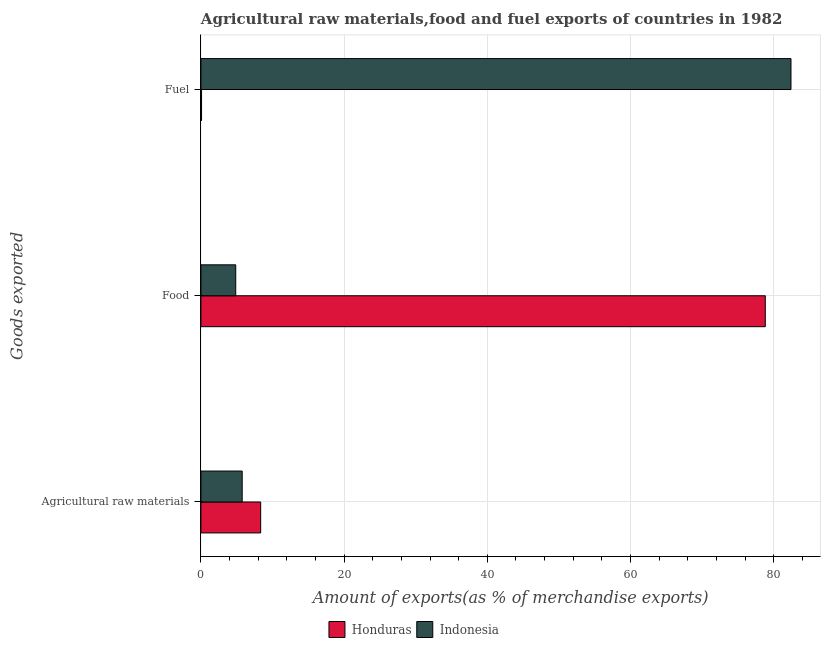How many groups of bars are there?
Your answer should be very brief. 3. Are the number of bars per tick equal to the number of legend labels?
Your answer should be very brief. Yes. What is the label of the 3rd group of bars from the top?
Your response must be concise. Agricultural raw materials. What is the percentage of food exports in Honduras?
Provide a short and direct response. 78.83. Across all countries, what is the maximum percentage of raw materials exports?
Provide a short and direct response. 8.35. Across all countries, what is the minimum percentage of food exports?
Ensure brevity in your answer.  4.86. In which country was the percentage of fuel exports maximum?
Your answer should be compact. Indonesia. What is the total percentage of fuel exports in the graph?
Your response must be concise. 82.5. What is the difference between the percentage of fuel exports in Honduras and that in Indonesia?
Your answer should be very brief. -82.33. What is the difference between the percentage of fuel exports in Indonesia and the percentage of food exports in Honduras?
Offer a terse response. 3.59. What is the average percentage of raw materials exports per country?
Provide a succinct answer. 7.05. What is the difference between the percentage of raw materials exports and percentage of fuel exports in Honduras?
Provide a succinct answer. 8.26. What is the ratio of the percentage of fuel exports in Honduras to that in Indonesia?
Your answer should be very brief. 0. Is the percentage of fuel exports in Indonesia less than that in Honduras?
Your response must be concise. No. What is the difference between the highest and the second highest percentage of food exports?
Your answer should be compact. 73.96. What is the difference between the highest and the lowest percentage of food exports?
Provide a succinct answer. 73.96. Is the sum of the percentage of fuel exports in Indonesia and Honduras greater than the maximum percentage of food exports across all countries?
Your answer should be compact. Yes. What does the 2nd bar from the top in Agricultural raw materials represents?
Offer a very short reply. Honduras. What does the 1st bar from the bottom in Agricultural raw materials represents?
Offer a terse response. Honduras. Are all the bars in the graph horizontal?
Your answer should be compact. Yes. How many countries are there in the graph?
Ensure brevity in your answer.  2. Does the graph contain any zero values?
Offer a terse response. No. Does the graph contain grids?
Your answer should be compact. Yes. Where does the legend appear in the graph?
Your response must be concise. Bottom center. How many legend labels are there?
Provide a short and direct response. 2. How are the legend labels stacked?
Your answer should be very brief. Horizontal. What is the title of the graph?
Offer a very short reply. Agricultural raw materials,food and fuel exports of countries in 1982. What is the label or title of the X-axis?
Give a very brief answer. Amount of exports(as % of merchandise exports). What is the label or title of the Y-axis?
Offer a terse response. Goods exported. What is the Amount of exports(as % of merchandise exports) of Honduras in Agricultural raw materials?
Offer a very short reply. 8.35. What is the Amount of exports(as % of merchandise exports) in Indonesia in Agricultural raw materials?
Offer a terse response. 5.76. What is the Amount of exports(as % of merchandise exports) in Honduras in Food?
Ensure brevity in your answer.  78.83. What is the Amount of exports(as % of merchandise exports) in Indonesia in Food?
Your answer should be compact. 4.86. What is the Amount of exports(as % of merchandise exports) of Honduras in Fuel?
Offer a very short reply. 0.09. What is the Amount of exports(as % of merchandise exports) in Indonesia in Fuel?
Offer a terse response. 82.41. Across all Goods exported, what is the maximum Amount of exports(as % of merchandise exports) in Honduras?
Offer a very short reply. 78.83. Across all Goods exported, what is the maximum Amount of exports(as % of merchandise exports) of Indonesia?
Offer a very short reply. 82.41. Across all Goods exported, what is the minimum Amount of exports(as % of merchandise exports) of Honduras?
Provide a short and direct response. 0.09. Across all Goods exported, what is the minimum Amount of exports(as % of merchandise exports) in Indonesia?
Your response must be concise. 4.86. What is the total Amount of exports(as % of merchandise exports) of Honduras in the graph?
Offer a terse response. 87.26. What is the total Amount of exports(as % of merchandise exports) in Indonesia in the graph?
Offer a terse response. 93.04. What is the difference between the Amount of exports(as % of merchandise exports) in Honduras in Agricultural raw materials and that in Food?
Provide a succinct answer. -70.48. What is the difference between the Amount of exports(as % of merchandise exports) in Indonesia in Agricultural raw materials and that in Food?
Make the answer very short. 0.9. What is the difference between the Amount of exports(as % of merchandise exports) in Honduras in Agricultural raw materials and that in Fuel?
Make the answer very short. 8.26. What is the difference between the Amount of exports(as % of merchandise exports) in Indonesia in Agricultural raw materials and that in Fuel?
Make the answer very short. -76.65. What is the difference between the Amount of exports(as % of merchandise exports) in Honduras in Food and that in Fuel?
Your answer should be very brief. 78.74. What is the difference between the Amount of exports(as % of merchandise exports) of Indonesia in Food and that in Fuel?
Provide a succinct answer. -77.55. What is the difference between the Amount of exports(as % of merchandise exports) of Honduras in Agricultural raw materials and the Amount of exports(as % of merchandise exports) of Indonesia in Food?
Your response must be concise. 3.48. What is the difference between the Amount of exports(as % of merchandise exports) in Honduras in Agricultural raw materials and the Amount of exports(as % of merchandise exports) in Indonesia in Fuel?
Your response must be concise. -74.07. What is the difference between the Amount of exports(as % of merchandise exports) of Honduras in Food and the Amount of exports(as % of merchandise exports) of Indonesia in Fuel?
Ensure brevity in your answer.  -3.59. What is the average Amount of exports(as % of merchandise exports) in Honduras per Goods exported?
Your response must be concise. 29.09. What is the average Amount of exports(as % of merchandise exports) in Indonesia per Goods exported?
Keep it short and to the point. 31.01. What is the difference between the Amount of exports(as % of merchandise exports) of Honduras and Amount of exports(as % of merchandise exports) of Indonesia in Agricultural raw materials?
Offer a terse response. 2.58. What is the difference between the Amount of exports(as % of merchandise exports) in Honduras and Amount of exports(as % of merchandise exports) in Indonesia in Food?
Keep it short and to the point. 73.96. What is the difference between the Amount of exports(as % of merchandise exports) of Honduras and Amount of exports(as % of merchandise exports) of Indonesia in Fuel?
Provide a succinct answer. -82.33. What is the ratio of the Amount of exports(as % of merchandise exports) of Honduras in Agricultural raw materials to that in Food?
Ensure brevity in your answer.  0.11. What is the ratio of the Amount of exports(as % of merchandise exports) in Indonesia in Agricultural raw materials to that in Food?
Your answer should be compact. 1.19. What is the ratio of the Amount of exports(as % of merchandise exports) in Honduras in Agricultural raw materials to that in Fuel?
Give a very brief answer. 94.02. What is the ratio of the Amount of exports(as % of merchandise exports) in Indonesia in Agricultural raw materials to that in Fuel?
Provide a succinct answer. 0.07. What is the ratio of the Amount of exports(as % of merchandise exports) of Honduras in Food to that in Fuel?
Give a very brief answer. 888.02. What is the ratio of the Amount of exports(as % of merchandise exports) in Indonesia in Food to that in Fuel?
Give a very brief answer. 0.06. What is the difference between the highest and the second highest Amount of exports(as % of merchandise exports) of Honduras?
Give a very brief answer. 70.48. What is the difference between the highest and the second highest Amount of exports(as % of merchandise exports) of Indonesia?
Make the answer very short. 76.65. What is the difference between the highest and the lowest Amount of exports(as % of merchandise exports) in Honduras?
Keep it short and to the point. 78.74. What is the difference between the highest and the lowest Amount of exports(as % of merchandise exports) of Indonesia?
Your answer should be compact. 77.55. 